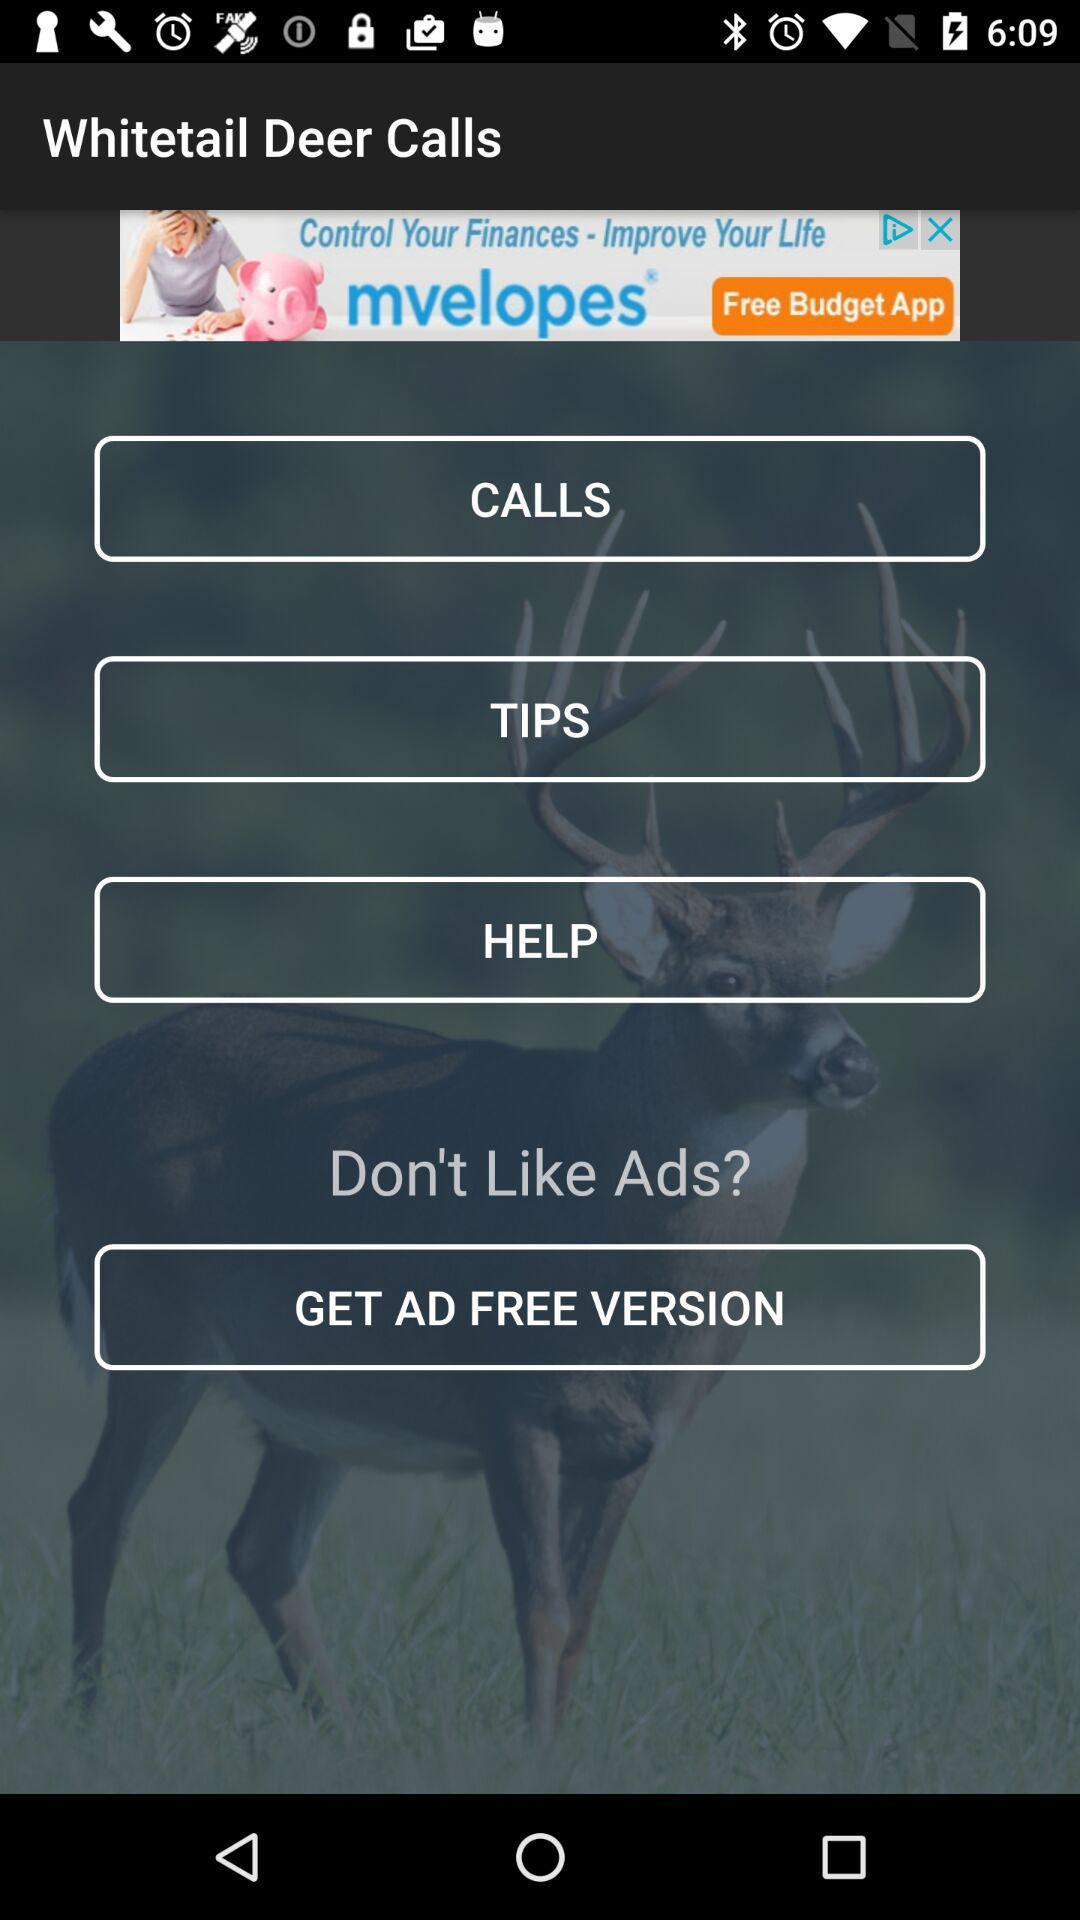What is the application name? The application name is "Whitetail Deer Calls". 